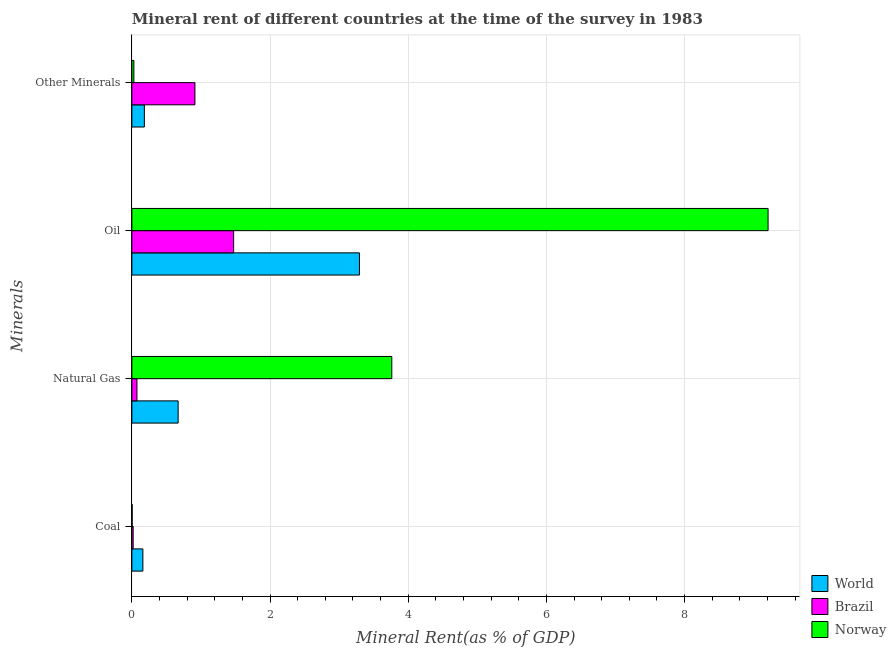How many different coloured bars are there?
Provide a succinct answer. 3. How many groups of bars are there?
Give a very brief answer. 4. Are the number of bars on each tick of the Y-axis equal?
Your response must be concise. Yes. How many bars are there on the 3rd tick from the top?
Make the answer very short. 3. How many bars are there on the 2nd tick from the bottom?
Your answer should be very brief. 3. What is the label of the 3rd group of bars from the top?
Give a very brief answer. Natural Gas. What is the  rent of other minerals in Norway?
Offer a terse response. 0.03. Across all countries, what is the maximum oil rent?
Give a very brief answer. 9.21. Across all countries, what is the minimum  rent of other minerals?
Your answer should be very brief. 0.03. What is the total coal rent in the graph?
Your answer should be very brief. 0.18. What is the difference between the  rent of other minerals in Brazil and that in Norway?
Offer a terse response. 0.88. What is the difference between the natural gas rent in Norway and the coal rent in Brazil?
Your answer should be compact. 3.74. What is the average  rent of other minerals per country?
Ensure brevity in your answer.  0.37. What is the difference between the coal rent and  rent of other minerals in Norway?
Your answer should be compact. -0.02. What is the ratio of the oil rent in World to that in Norway?
Provide a succinct answer. 0.36. Is the natural gas rent in World less than that in Norway?
Provide a short and direct response. Yes. What is the difference between the highest and the second highest oil rent?
Provide a short and direct response. 5.91. What is the difference between the highest and the lowest natural gas rent?
Provide a short and direct response. 3.69. In how many countries, is the  rent of other minerals greater than the average  rent of other minerals taken over all countries?
Give a very brief answer. 1. Is the sum of the oil rent in Brazil and Norway greater than the maximum coal rent across all countries?
Give a very brief answer. Yes. How many bars are there?
Keep it short and to the point. 12. Are all the bars in the graph horizontal?
Your answer should be compact. Yes. How many countries are there in the graph?
Your response must be concise. 3. Are the values on the major ticks of X-axis written in scientific E-notation?
Provide a succinct answer. No. Does the graph contain grids?
Provide a short and direct response. Yes. Where does the legend appear in the graph?
Make the answer very short. Bottom right. How many legend labels are there?
Provide a succinct answer. 3. How are the legend labels stacked?
Offer a terse response. Vertical. What is the title of the graph?
Provide a succinct answer. Mineral rent of different countries at the time of the survey in 1983. What is the label or title of the X-axis?
Offer a very short reply. Mineral Rent(as % of GDP). What is the label or title of the Y-axis?
Offer a terse response. Minerals. What is the Mineral Rent(as % of GDP) of World in Coal?
Offer a terse response. 0.16. What is the Mineral Rent(as % of GDP) of Brazil in Coal?
Provide a short and direct response. 0.02. What is the Mineral Rent(as % of GDP) of Norway in Coal?
Provide a short and direct response. 0. What is the Mineral Rent(as % of GDP) in World in Natural Gas?
Provide a short and direct response. 0.67. What is the Mineral Rent(as % of GDP) in Brazil in Natural Gas?
Ensure brevity in your answer.  0.07. What is the Mineral Rent(as % of GDP) in Norway in Natural Gas?
Your answer should be very brief. 3.76. What is the Mineral Rent(as % of GDP) in World in Oil?
Your answer should be very brief. 3.29. What is the Mineral Rent(as % of GDP) of Brazil in Oil?
Give a very brief answer. 1.47. What is the Mineral Rent(as % of GDP) of Norway in Oil?
Your answer should be compact. 9.21. What is the Mineral Rent(as % of GDP) of World in Other Minerals?
Make the answer very short. 0.18. What is the Mineral Rent(as % of GDP) of Brazil in Other Minerals?
Offer a very short reply. 0.91. What is the Mineral Rent(as % of GDP) in Norway in Other Minerals?
Offer a terse response. 0.03. Across all Minerals, what is the maximum Mineral Rent(as % of GDP) in World?
Your answer should be very brief. 3.29. Across all Minerals, what is the maximum Mineral Rent(as % of GDP) in Brazil?
Your answer should be compact. 1.47. Across all Minerals, what is the maximum Mineral Rent(as % of GDP) in Norway?
Keep it short and to the point. 9.21. Across all Minerals, what is the minimum Mineral Rent(as % of GDP) in World?
Your answer should be very brief. 0.16. Across all Minerals, what is the minimum Mineral Rent(as % of GDP) in Brazil?
Keep it short and to the point. 0.02. Across all Minerals, what is the minimum Mineral Rent(as % of GDP) of Norway?
Your answer should be very brief. 0. What is the total Mineral Rent(as % of GDP) in World in the graph?
Your response must be concise. 4.3. What is the total Mineral Rent(as % of GDP) in Brazil in the graph?
Provide a short and direct response. 2.48. What is the total Mineral Rent(as % of GDP) of Norway in the graph?
Offer a terse response. 13. What is the difference between the Mineral Rent(as % of GDP) in World in Coal and that in Natural Gas?
Provide a short and direct response. -0.51. What is the difference between the Mineral Rent(as % of GDP) of Brazil in Coal and that in Natural Gas?
Provide a short and direct response. -0.05. What is the difference between the Mineral Rent(as % of GDP) of Norway in Coal and that in Natural Gas?
Provide a short and direct response. -3.76. What is the difference between the Mineral Rent(as % of GDP) in World in Coal and that in Oil?
Your response must be concise. -3.13. What is the difference between the Mineral Rent(as % of GDP) in Brazil in Coal and that in Oil?
Ensure brevity in your answer.  -1.45. What is the difference between the Mineral Rent(as % of GDP) of Norway in Coal and that in Oil?
Give a very brief answer. -9.2. What is the difference between the Mineral Rent(as % of GDP) in World in Coal and that in Other Minerals?
Your answer should be very brief. -0.02. What is the difference between the Mineral Rent(as % of GDP) in Brazil in Coal and that in Other Minerals?
Your answer should be very brief. -0.89. What is the difference between the Mineral Rent(as % of GDP) in Norway in Coal and that in Other Minerals?
Give a very brief answer. -0.02. What is the difference between the Mineral Rent(as % of GDP) of World in Natural Gas and that in Oil?
Your response must be concise. -2.62. What is the difference between the Mineral Rent(as % of GDP) in Brazil in Natural Gas and that in Oil?
Offer a terse response. -1.4. What is the difference between the Mineral Rent(as % of GDP) in Norway in Natural Gas and that in Oil?
Ensure brevity in your answer.  -5.45. What is the difference between the Mineral Rent(as % of GDP) of World in Natural Gas and that in Other Minerals?
Make the answer very short. 0.49. What is the difference between the Mineral Rent(as % of GDP) in Brazil in Natural Gas and that in Other Minerals?
Your response must be concise. -0.84. What is the difference between the Mineral Rent(as % of GDP) in Norway in Natural Gas and that in Other Minerals?
Ensure brevity in your answer.  3.73. What is the difference between the Mineral Rent(as % of GDP) in World in Oil and that in Other Minerals?
Make the answer very short. 3.11. What is the difference between the Mineral Rent(as % of GDP) in Brazil in Oil and that in Other Minerals?
Your answer should be very brief. 0.56. What is the difference between the Mineral Rent(as % of GDP) of Norway in Oil and that in Other Minerals?
Offer a very short reply. 9.18. What is the difference between the Mineral Rent(as % of GDP) in World in Coal and the Mineral Rent(as % of GDP) in Brazil in Natural Gas?
Make the answer very short. 0.09. What is the difference between the Mineral Rent(as % of GDP) in World in Coal and the Mineral Rent(as % of GDP) in Norway in Natural Gas?
Provide a short and direct response. -3.6. What is the difference between the Mineral Rent(as % of GDP) of Brazil in Coal and the Mineral Rent(as % of GDP) of Norway in Natural Gas?
Make the answer very short. -3.74. What is the difference between the Mineral Rent(as % of GDP) of World in Coal and the Mineral Rent(as % of GDP) of Brazil in Oil?
Offer a terse response. -1.31. What is the difference between the Mineral Rent(as % of GDP) in World in Coal and the Mineral Rent(as % of GDP) in Norway in Oil?
Your response must be concise. -9.05. What is the difference between the Mineral Rent(as % of GDP) in Brazil in Coal and the Mineral Rent(as % of GDP) in Norway in Oil?
Keep it short and to the point. -9.19. What is the difference between the Mineral Rent(as % of GDP) of World in Coal and the Mineral Rent(as % of GDP) of Brazil in Other Minerals?
Give a very brief answer. -0.75. What is the difference between the Mineral Rent(as % of GDP) in World in Coal and the Mineral Rent(as % of GDP) in Norway in Other Minerals?
Offer a terse response. 0.13. What is the difference between the Mineral Rent(as % of GDP) of Brazil in Coal and the Mineral Rent(as % of GDP) of Norway in Other Minerals?
Give a very brief answer. -0.01. What is the difference between the Mineral Rent(as % of GDP) of World in Natural Gas and the Mineral Rent(as % of GDP) of Brazil in Oil?
Make the answer very short. -0.8. What is the difference between the Mineral Rent(as % of GDP) of World in Natural Gas and the Mineral Rent(as % of GDP) of Norway in Oil?
Give a very brief answer. -8.54. What is the difference between the Mineral Rent(as % of GDP) of Brazil in Natural Gas and the Mineral Rent(as % of GDP) of Norway in Oil?
Provide a succinct answer. -9.14. What is the difference between the Mineral Rent(as % of GDP) of World in Natural Gas and the Mineral Rent(as % of GDP) of Brazil in Other Minerals?
Provide a succinct answer. -0.24. What is the difference between the Mineral Rent(as % of GDP) in World in Natural Gas and the Mineral Rent(as % of GDP) in Norway in Other Minerals?
Your response must be concise. 0.64. What is the difference between the Mineral Rent(as % of GDP) in Brazil in Natural Gas and the Mineral Rent(as % of GDP) in Norway in Other Minerals?
Ensure brevity in your answer.  0.04. What is the difference between the Mineral Rent(as % of GDP) in World in Oil and the Mineral Rent(as % of GDP) in Brazil in Other Minerals?
Ensure brevity in your answer.  2.38. What is the difference between the Mineral Rent(as % of GDP) of World in Oil and the Mineral Rent(as % of GDP) of Norway in Other Minerals?
Your response must be concise. 3.27. What is the difference between the Mineral Rent(as % of GDP) in Brazil in Oil and the Mineral Rent(as % of GDP) in Norway in Other Minerals?
Offer a terse response. 1.44. What is the average Mineral Rent(as % of GDP) of World per Minerals?
Give a very brief answer. 1.08. What is the average Mineral Rent(as % of GDP) of Brazil per Minerals?
Provide a succinct answer. 0.62. What is the average Mineral Rent(as % of GDP) in Norway per Minerals?
Provide a short and direct response. 3.25. What is the difference between the Mineral Rent(as % of GDP) of World and Mineral Rent(as % of GDP) of Brazil in Coal?
Ensure brevity in your answer.  0.14. What is the difference between the Mineral Rent(as % of GDP) of World and Mineral Rent(as % of GDP) of Norway in Coal?
Provide a succinct answer. 0.15. What is the difference between the Mineral Rent(as % of GDP) in Brazil and Mineral Rent(as % of GDP) in Norway in Coal?
Your answer should be very brief. 0.01. What is the difference between the Mineral Rent(as % of GDP) of World and Mineral Rent(as % of GDP) of Brazil in Natural Gas?
Make the answer very short. 0.6. What is the difference between the Mineral Rent(as % of GDP) in World and Mineral Rent(as % of GDP) in Norway in Natural Gas?
Offer a very short reply. -3.09. What is the difference between the Mineral Rent(as % of GDP) of Brazil and Mineral Rent(as % of GDP) of Norway in Natural Gas?
Ensure brevity in your answer.  -3.69. What is the difference between the Mineral Rent(as % of GDP) of World and Mineral Rent(as % of GDP) of Brazil in Oil?
Keep it short and to the point. 1.82. What is the difference between the Mineral Rent(as % of GDP) in World and Mineral Rent(as % of GDP) in Norway in Oil?
Offer a very short reply. -5.91. What is the difference between the Mineral Rent(as % of GDP) of Brazil and Mineral Rent(as % of GDP) of Norway in Oil?
Keep it short and to the point. -7.74. What is the difference between the Mineral Rent(as % of GDP) in World and Mineral Rent(as % of GDP) in Brazil in Other Minerals?
Your answer should be very brief. -0.73. What is the difference between the Mineral Rent(as % of GDP) of World and Mineral Rent(as % of GDP) of Norway in Other Minerals?
Your answer should be very brief. 0.15. What is the difference between the Mineral Rent(as % of GDP) in Brazil and Mineral Rent(as % of GDP) in Norway in Other Minerals?
Give a very brief answer. 0.88. What is the ratio of the Mineral Rent(as % of GDP) of World in Coal to that in Natural Gas?
Provide a succinct answer. 0.24. What is the ratio of the Mineral Rent(as % of GDP) in Brazil in Coal to that in Natural Gas?
Ensure brevity in your answer.  0.25. What is the ratio of the Mineral Rent(as % of GDP) in Norway in Coal to that in Natural Gas?
Your answer should be very brief. 0. What is the ratio of the Mineral Rent(as % of GDP) of World in Coal to that in Oil?
Offer a terse response. 0.05. What is the ratio of the Mineral Rent(as % of GDP) in Brazil in Coal to that in Oil?
Your response must be concise. 0.01. What is the ratio of the Mineral Rent(as % of GDP) in Norway in Coal to that in Oil?
Your answer should be very brief. 0. What is the ratio of the Mineral Rent(as % of GDP) in World in Coal to that in Other Minerals?
Your answer should be very brief. 0.88. What is the ratio of the Mineral Rent(as % of GDP) in Brazil in Coal to that in Other Minerals?
Provide a short and direct response. 0.02. What is the ratio of the Mineral Rent(as % of GDP) of Norway in Coal to that in Other Minerals?
Your answer should be compact. 0.15. What is the ratio of the Mineral Rent(as % of GDP) in World in Natural Gas to that in Oil?
Keep it short and to the point. 0.2. What is the ratio of the Mineral Rent(as % of GDP) in Brazil in Natural Gas to that in Oil?
Offer a terse response. 0.05. What is the ratio of the Mineral Rent(as % of GDP) in Norway in Natural Gas to that in Oil?
Your answer should be compact. 0.41. What is the ratio of the Mineral Rent(as % of GDP) in World in Natural Gas to that in Other Minerals?
Provide a short and direct response. 3.71. What is the ratio of the Mineral Rent(as % of GDP) in Brazil in Natural Gas to that in Other Minerals?
Keep it short and to the point. 0.08. What is the ratio of the Mineral Rent(as % of GDP) of Norway in Natural Gas to that in Other Minerals?
Provide a short and direct response. 129. What is the ratio of the Mineral Rent(as % of GDP) in World in Oil to that in Other Minerals?
Keep it short and to the point. 18.24. What is the ratio of the Mineral Rent(as % of GDP) in Brazil in Oil to that in Other Minerals?
Make the answer very short. 1.61. What is the ratio of the Mineral Rent(as % of GDP) in Norway in Oil to that in Other Minerals?
Give a very brief answer. 315.74. What is the difference between the highest and the second highest Mineral Rent(as % of GDP) in World?
Offer a terse response. 2.62. What is the difference between the highest and the second highest Mineral Rent(as % of GDP) in Brazil?
Your response must be concise. 0.56. What is the difference between the highest and the second highest Mineral Rent(as % of GDP) in Norway?
Ensure brevity in your answer.  5.45. What is the difference between the highest and the lowest Mineral Rent(as % of GDP) in World?
Provide a short and direct response. 3.13. What is the difference between the highest and the lowest Mineral Rent(as % of GDP) in Brazil?
Provide a short and direct response. 1.45. What is the difference between the highest and the lowest Mineral Rent(as % of GDP) of Norway?
Keep it short and to the point. 9.2. 